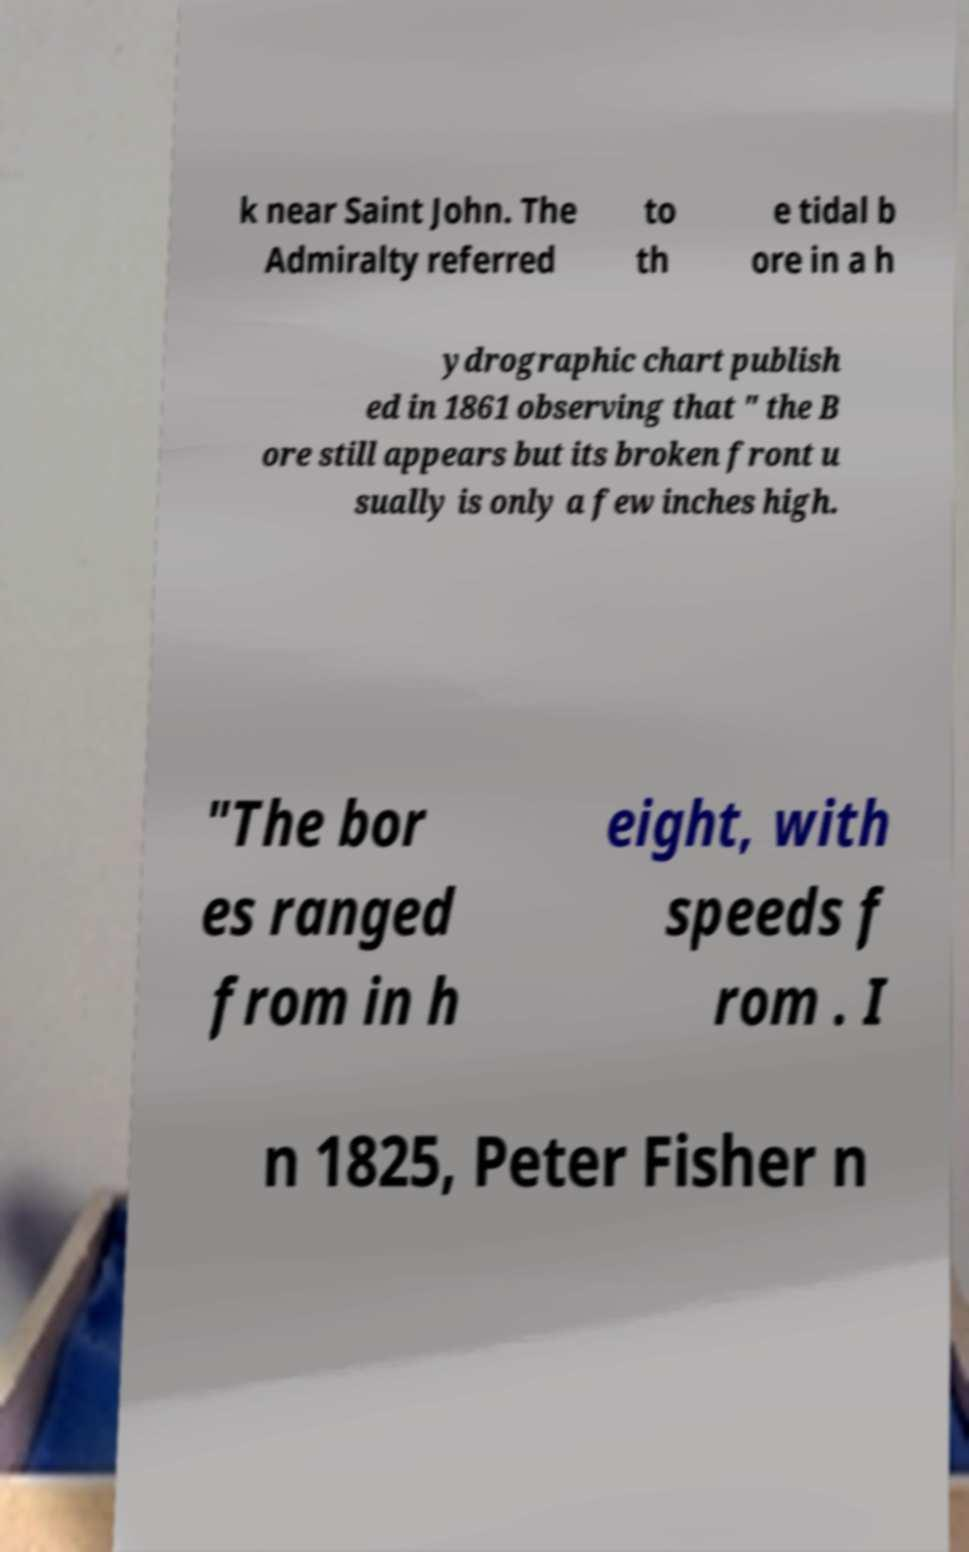For documentation purposes, I need the text within this image transcribed. Could you provide that? k near Saint John. The Admiralty referred to th e tidal b ore in a h ydrographic chart publish ed in 1861 observing that " the B ore still appears but its broken front u sually is only a few inches high. "The bor es ranged from in h eight, with speeds f rom . I n 1825, Peter Fisher n 